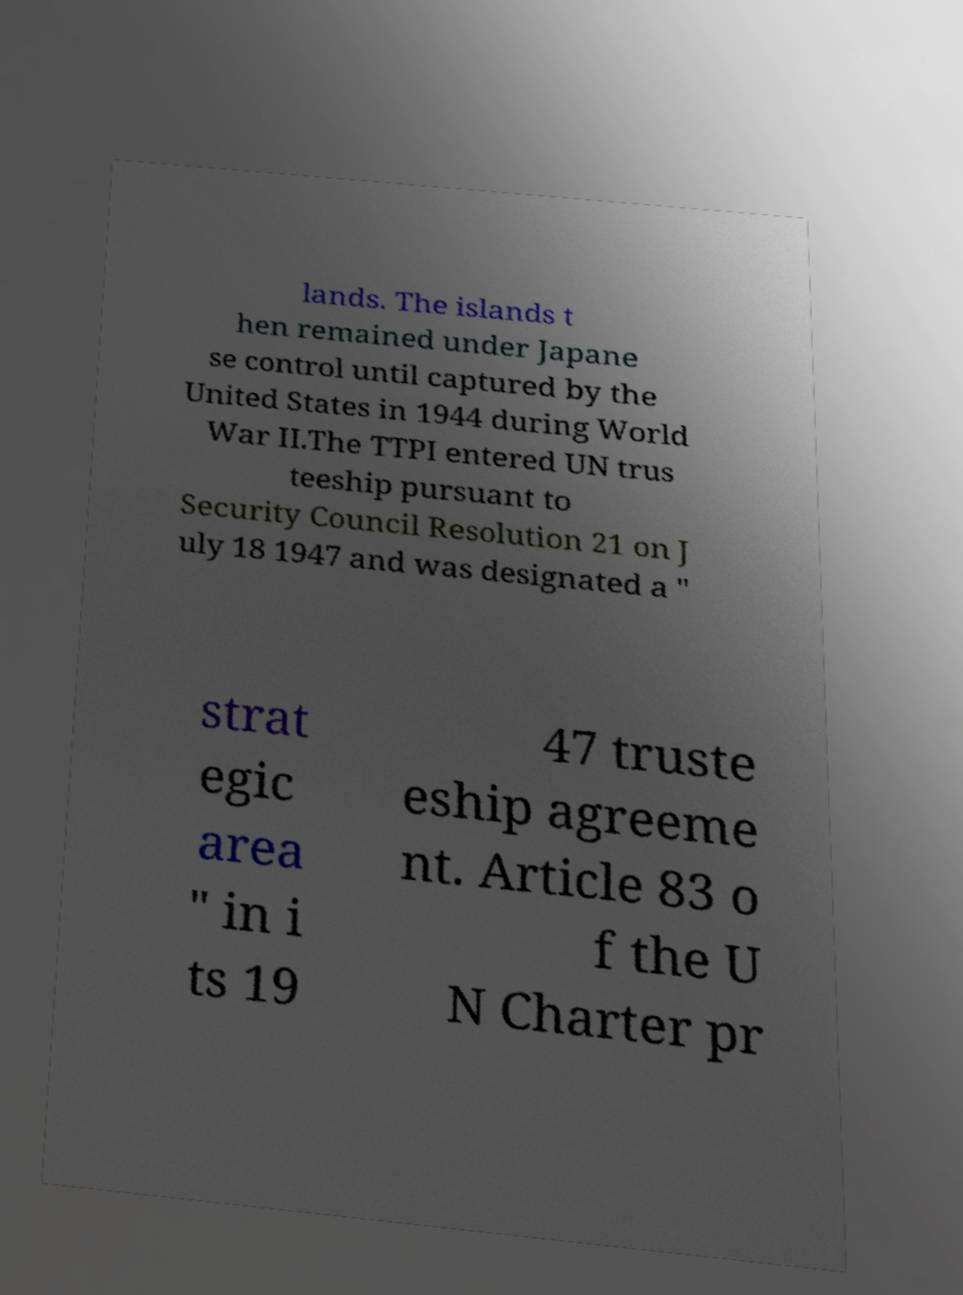For documentation purposes, I need the text within this image transcribed. Could you provide that? lands. The islands t hen remained under Japane se control until captured by the United States in 1944 during World War II.The TTPI entered UN trus teeship pursuant to Security Council Resolution 21 on J uly 18 1947 and was designated a " strat egic area " in i ts 19 47 truste eship agreeme nt. Article 83 o f the U N Charter pr 